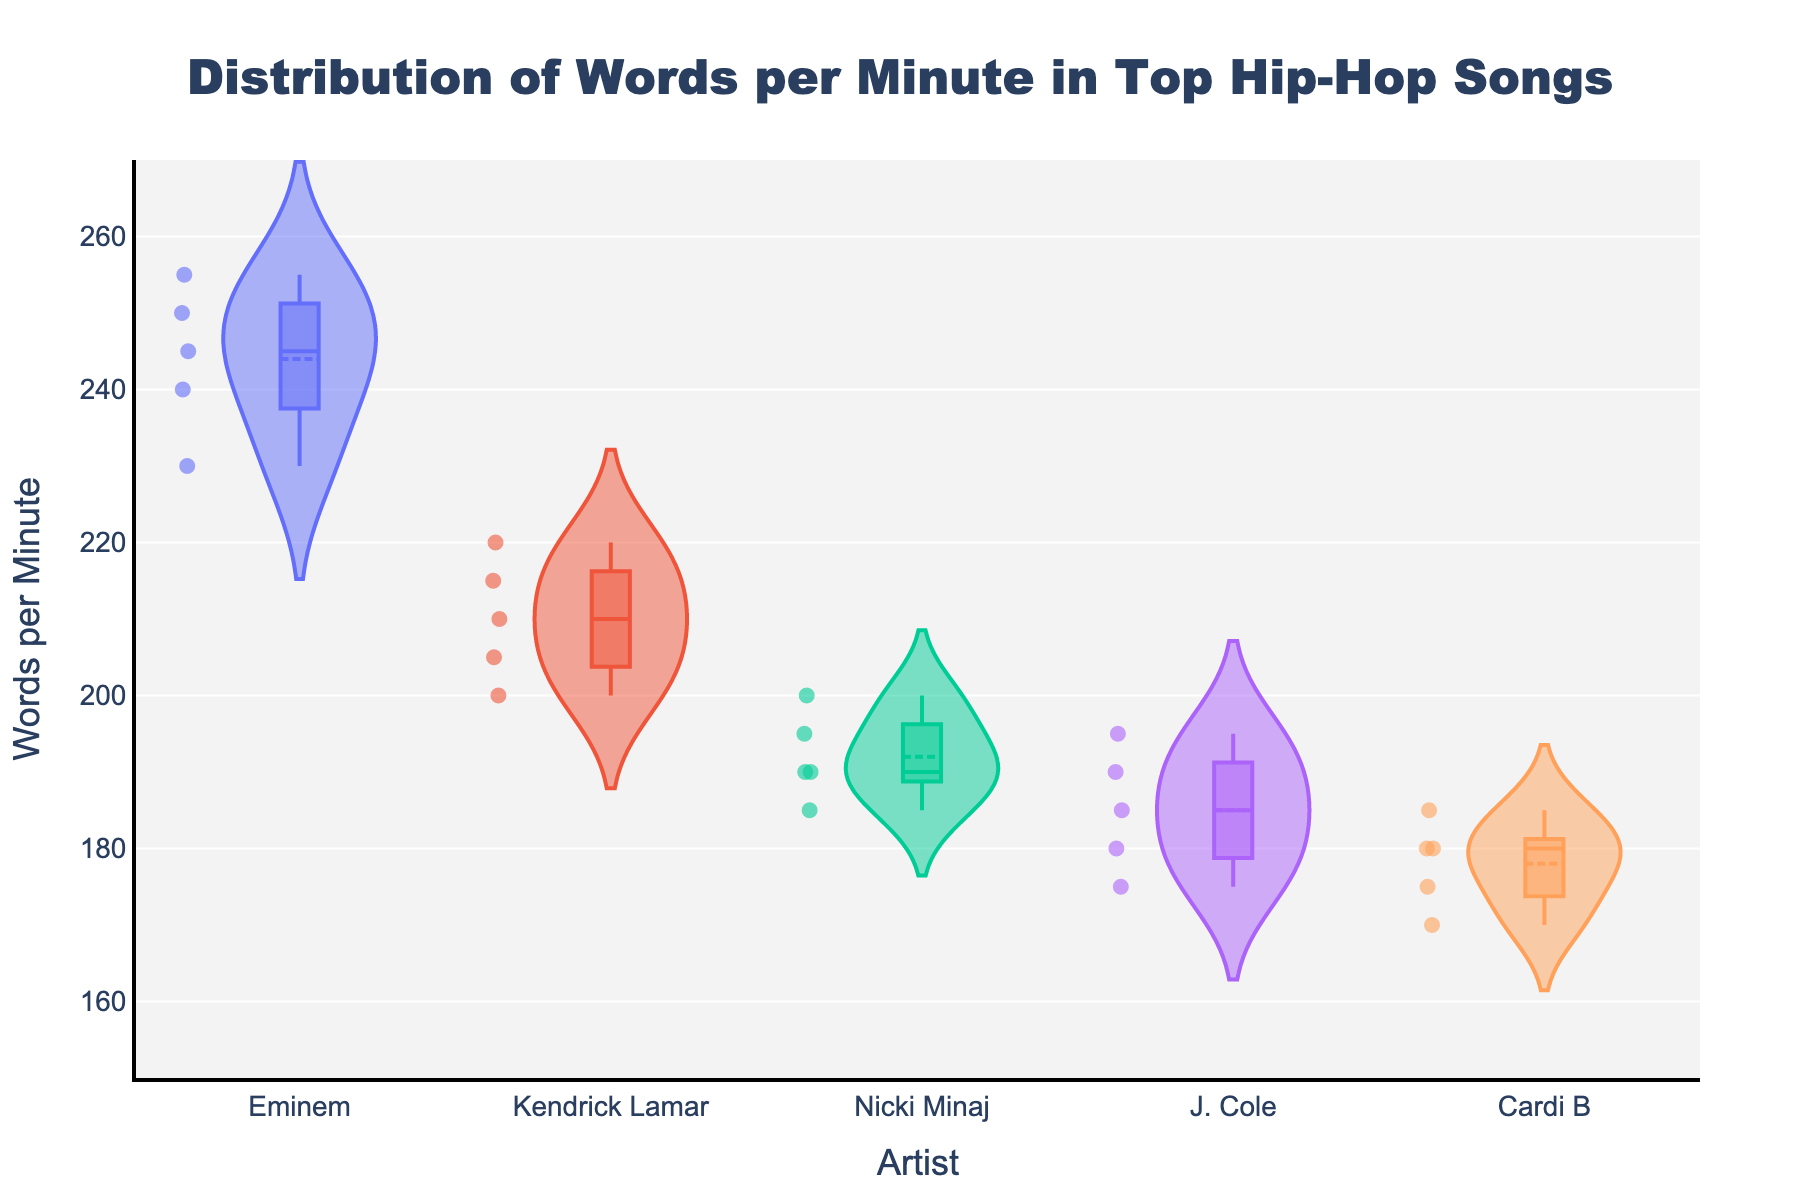What is the title of the figure? The title is usually placed at the top of the figure. By reading it, we can identify its topic. In this figure, the title reads "Distribution of Words per Minute in Top Hip-Hop Songs".
Answer: Distribution of Words per Minute in Top Hip-Hop Songs How many artists are represented in the figure? By counting the number of unique labels on the x-axis, we can determine the number of artists. There are five distinct names listed: Eminem, Kendrick Lamar, Nicki Minaj, J. Cole, and Cardi B.
Answer: 5 Which artist has the highest range of words per minute? The length of each violin plot indicates the range. Eminem's violin plot extends from around 230 to 255, which is the largest range compared to the others.
Answer: Eminem What are the mean words per minute for Nicki Minaj and Cardi B? The mean is represented by the horizontal line within the violin plot. For Nicki Minaj, it's around 192.5, and for Cardi B, it's roughly 178.
Answer: Nicki Minaj: 192.5, Cardi B: 178 Which artist's songs have the most variability in words per minute? Variability can be measured by the width of the violin plots. A wider plot indicates more spread out data. Eminem's plot is the widest, signifying the most variability.
Answer: Eminem What's the median value of words per minute for Kendrick Lamar? The median is the middle value in the dataset. It is indicated by a small horizontal line within the violin plot's box. For Kendrick Lamar, this is approximately 210.
Answer: 210 How do Eminem's and J. Cole's word distributions compare in terms of median words per minute? By observing the central tendency line in the violin plots, Eminem's median is higher (around 245) compared to J. Cole's (roughly 185).
Answer: Eminem's median is higher Which artist has the narrowest distribution of words per minute? The narrowest distribution is seen in the artist with the smallest width of the violin plot. Cardi B's plot is the narrowest, indicating less variability.
Answer: Cardi B Which artist shows the lowest words per minute in their songs? The lowest value on the y-axis within any violin plot represents this. J. Cole has songs with words per minute as low as 175.
Answer: J. Cole Do any artists have overlaps in their words per minute distributions? Overlaps are seen where violin plots span similar ranges. For example, Nicki Minaj's range (around 185-200) overlaps with parts of J. Cole's (about 175-195) and Cardi B's distributions (around 170-185).
Answer: Yes 